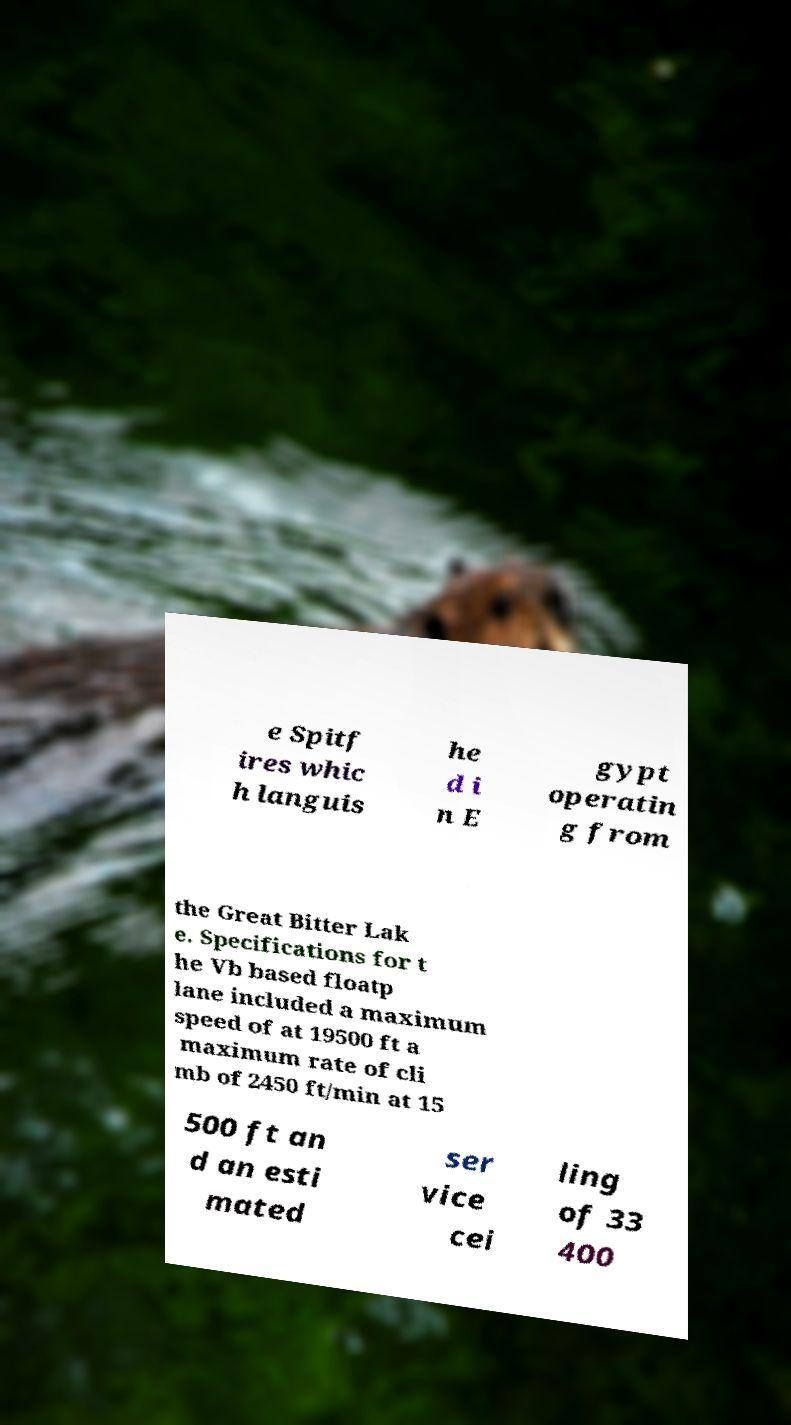There's text embedded in this image that I need extracted. Can you transcribe it verbatim? e Spitf ires whic h languis he d i n E gypt operatin g from the Great Bitter Lak e. Specifications for t he Vb based floatp lane included a maximum speed of at 19500 ft a maximum rate of cli mb of 2450 ft/min at 15 500 ft an d an esti mated ser vice cei ling of 33 400 